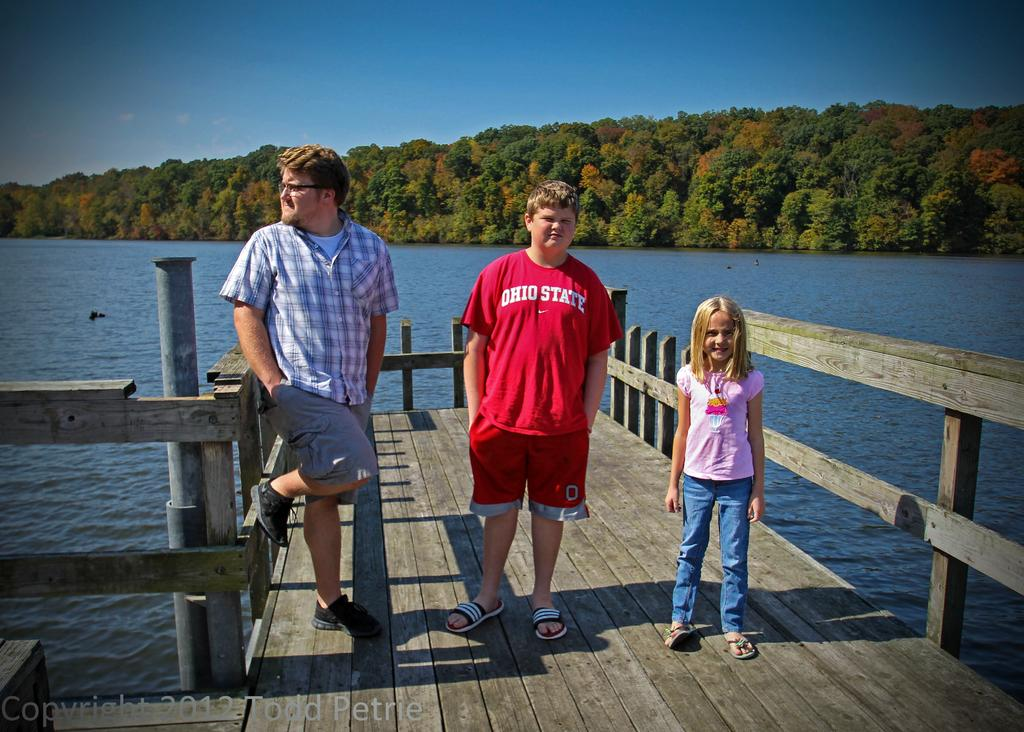What type of structure is present in the image? There is a walkway bridge in the image. What are the people on the bridge doing? People are standing on the bridge. What can be seen in the background of the image? There is water, trees, and the sky visible in the background of the image. What type of flower is growing on the bridge in the image? There are no flowers visible on the bridge in the image. 